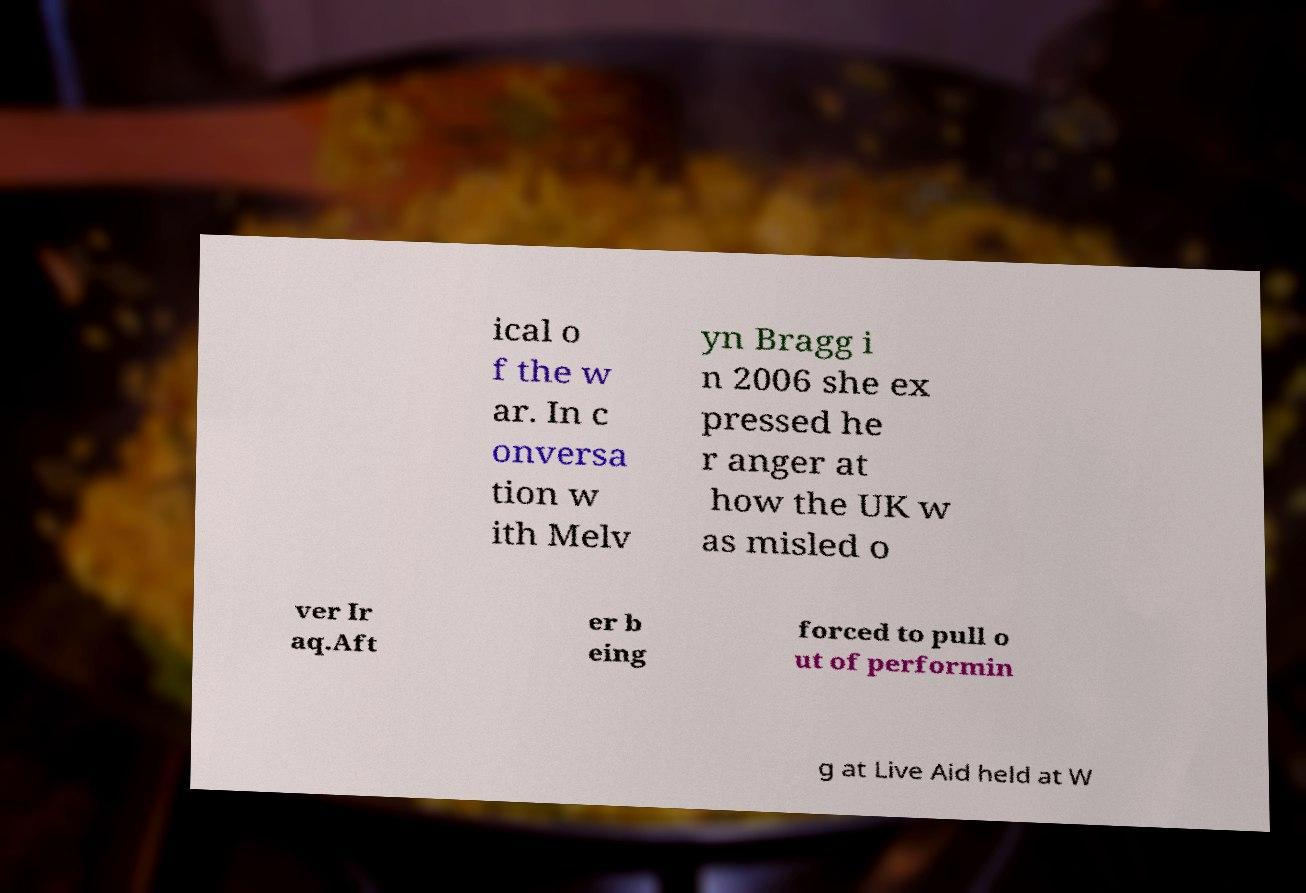Please read and relay the text visible in this image. What does it say? ical o f the w ar. In c onversa tion w ith Melv yn Bragg i n 2006 she ex pressed he r anger at how the UK w as misled o ver Ir aq.Aft er b eing forced to pull o ut of performin g at Live Aid held at W 